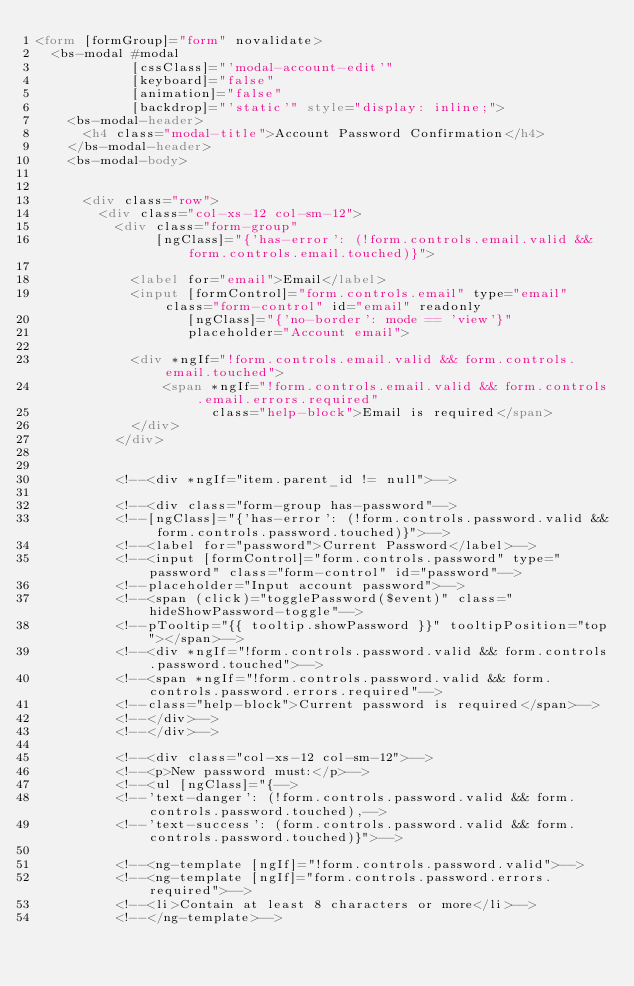Convert code to text. <code><loc_0><loc_0><loc_500><loc_500><_HTML_><form [formGroup]="form" novalidate>
  <bs-modal #modal
            [cssClass]="'modal-account-edit'"
            [keyboard]="false"
            [animation]="false"
            [backdrop]="'static'" style="display: inline;">
    <bs-modal-header>
      <h4 class="modal-title">Account Password Confirmation</h4>
    </bs-modal-header>
    <bs-modal-body>


      <div class="row">
        <div class="col-xs-12 col-sm-12">
          <div class="form-group"
               [ngClass]="{'has-error': (!form.controls.email.valid && form.controls.email.touched)}">

            <label for="email">Email</label>
            <input [formControl]="form.controls.email" type="email" class="form-control" id="email" readonly
                   [ngClass]="{'no-border': mode == 'view'}"
                   placeholder="Account email">

            <div *ngIf="!form.controls.email.valid && form.controls.email.touched">
                <span *ngIf="!form.controls.email.valid && form.controls.email.errors.required"
                      class="help-block">Email is required</span>
            </div>
          </div>


          <!--<div *ngIf="item.parent_id != null">-->

          <!--<div class="form-group has-password"-->
          <!--[ngClass]="{'has-error': (!form.controls.password.valid && form.controls.password.touched)}">-->
          <!--<label for="password">Current Password</label>-->
          <!--<input [formControl]="form.controls.password" type="password" class="form-control" id="password"-->
          <!--placeholder="Input account password">-->
          <!--<span (click)="togglePassword($event)" class="hideShowPassword-toggle"-->
          <!--pTooltip="{{ tooltip.showPassword }}" tooltipPosition="top"></span>-->
          <!--<div *ngIf="!form.controls.password.valid && form.controls.password.touched">-->
          <!--<span *ngIf="!form.controls.password.valid && form.controls.password.errors.required"-->
          <!--class="help-block">Current password is required</span>-->
          <!--</div>-->
          <!--</div>-->

          <!--<div class="col-xs-12 col-sm-12">-->
          <!--<p>New password must:</p>-->
          <!--<ul [ngClass]="{-->
          <!--'text-danger': (!form.controls.password.valid && form.controls.password.touched),-->
          <!--'text-success': (form.controls.password.valid && form.controls.password.touched)}">-->

          <!--<ng-template [ngIf]="!form.controls.password.valid">-->
          <!--<ng-template [ngIf]="form.controls.password.errors.required">-->
          <!--<li>Contain at least 8 characters or more</li>-->
          <!--</ng-template>--></code> 